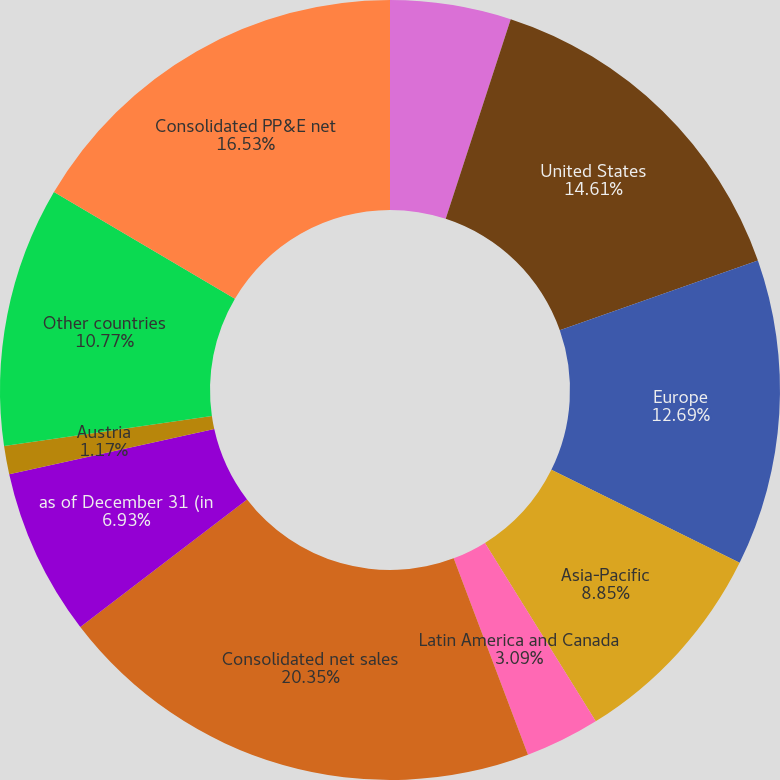<chart> <loc_0><loc_0><loc_500><loc_500><pie_chart><fcel>years ended December 31 (in<fcel>United States<fcel>Europe<fcel>Asia-Pacific<fcel>Latin America and Canada<fcel>Consolidated net sales<fcel>as of December 31 (in<fcel>Austria<fcel>Other countries<fcel>Consolidated PP&E net<nl><fcel>5.01%<fcel>14.61%<fcel>12.69%<fcel>8.85%<fcel>3.09%<fcel>20.36%<fcel>6.93%<fcel>1.17%<fcel>10.77%<fcel>16.53%<nl></chart> 